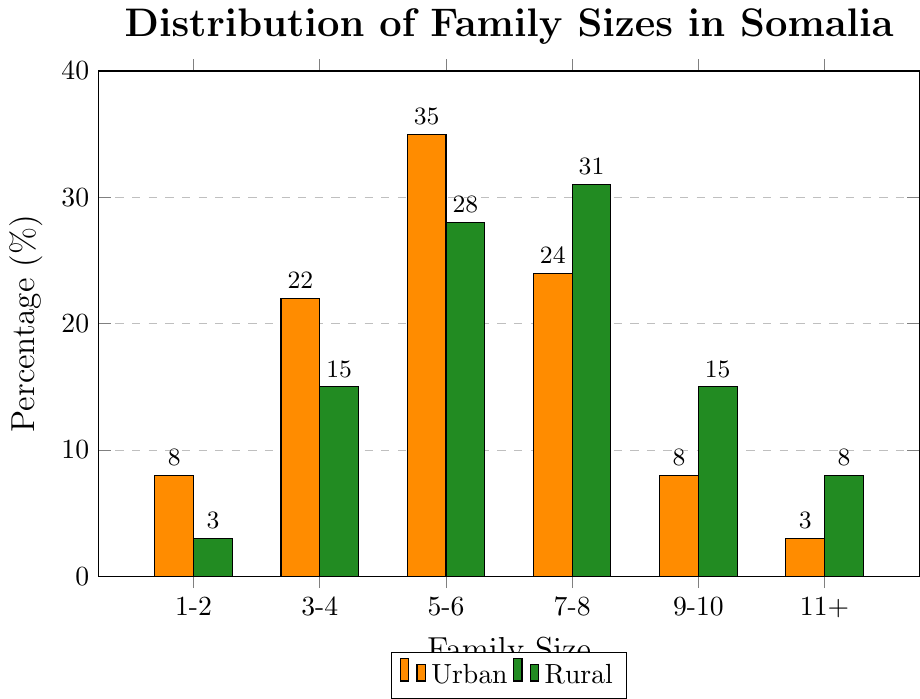Which family size category has the highest percentage in urban areas? In the urban areas, the bar representing "5-6 members" has the highest height among all categories in the urban plot. Thus, this category has the highest percentage.
Answer: 5-6 members Which family size category has a higher percentage in rural areas compared to urban areas? By looking at the heights of the bars, "7-8 members," "9-10 members," and "11+ members" categories have taller bars in rural areas than in urban areas.
Answer: 7-8 members, 9-10 members, 11+ members What is the percentage difference of 3-4 member families between urban and rural areas? The percentage for 3-4 member families in urban areas is 22% and in rural areas is 15%. The difference is calculated as 22% - 15%.
Answer: 7% Which area (urban or rural) has a higher percentage of families with 1-2 members, and by how much? The percentage for 1-2 member families in urban areas is 8% and in rural areas is 3%. Urban areas have a higher percentage by 8% - 3%.
Answer: Urban, 5% What is the combined percentage of families with 5-6 members and 7-8 members in rural areas? In rural areas, families with 5-6 members are 28% and families with 7-8 members are 31%. The combined percentage is 28% + 31%.
Answer: 59% How does the percentage of families with 11+ members in rural areas compare to that in urban areas? The percentage of families with 11+ members in rural areas is 8% and in urban areas is 3%. Comparing these, rural areas have a higher percentage.
Answer: Rural higher Out of the six family size categories, which one has the lowest percentage in urban areas, and what is this percentage? The lowest bar in the urban area corresponds to the "11+ members" category. The percentage for this category is 3%.
Answer: 11+ members, 3% How much higher is the percentage of families with 7-8 members in rural areas compared to urban areas? The percentage for 7-8 member families in rural areas is 31% and in urban areas is 24%. The difference is 31% - 24%.
Answer: 7% Which family size category shows the highest discrepancy in percentage between urban and rural areas? By comparing the heights of the bars, the "9-10 members" family size category shows the highest discrepancy, with a difference of 15% (rural) - 8% (urban) = 7%.
Answer: 9-10 members What is the total percentage of families with fewer than 5 members in urban areas? In urban areas, 1-2 member families make up 8% and 3-4 member families make up 22%. The total percentage is 8% + 22%.
Answer: 30% 